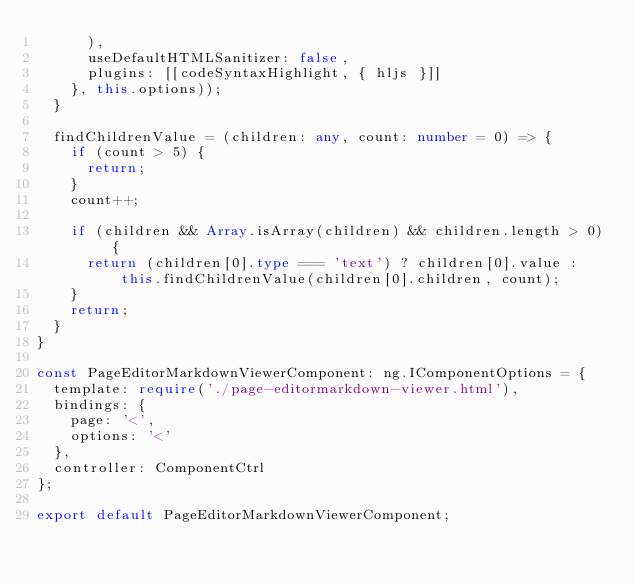Convert code to text. <code><loc_0><loc_0><loc_500><loc_500><_TypeScript_>      ),
      useDefaultHTMLSanitizer: false,
      plugins: [[codeSyntaxHighlight, { hljs }]]
    }, this.options));
  }

  findChildrenValue = (children: any, count: number = 0) => {
    if (count > 5) {
      return;
    }
    count++;

    if (children && Array.isArray(children) && children.length > 0) {
      return (children[0].type === 'text') ? children[0].value : this.findChildrenValue(children[0].children, count);
    }
    return;
  }
}

const PageEditorMarkdownViewerComponent: ng.IComponentOptions = {
  template: require('./page-editormarkdown-viewer.html'),
  bindings: {
    page: '<',
    options: '<'
  },
  controller: ComponentCtrl
};

export default PageEditorMarkdownViewerComponent;
</code> 